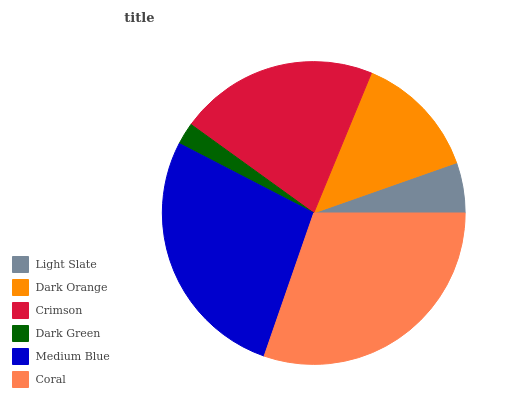Is Dark Green the minimum?
Answer yes or no. Yes. Is Coral the maximum?
Answer yes or no. Yes. Is Dark Orange the minimum?
Answer yes or no. No. Is Dark Orange the maximum?
Answer yes or no. No. Is Dark Orange greater than Light Slate?
Answer yes or no. Yes. Is Light Slate less than Dark Orange?
Answer yes or no. Yes. Is Light Slate greater than Dark Orange?
Answer yes or no. No. Is Dark Orange less than Light Slate?
Answer yes or no. No. Is Crimson the high median?
Answer yes or no. Yes. Is Dark Orange the low median?
Answer yes or no. Yes. Is Light Slate the high median?
Answer yes or no. No. Is Coral the low median?
Answer yes or no. No. 